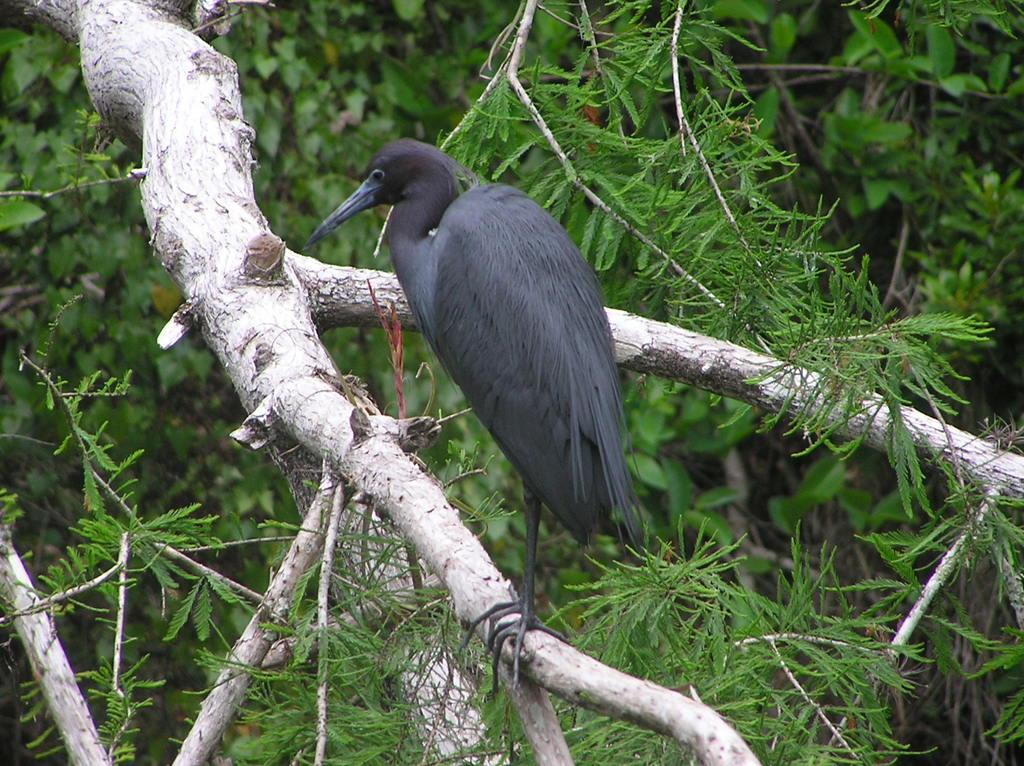What type of animal can be seen in the image? There is a bird in the image. Where is the bird located? The bird is on a tree branch. What can be seen in the background of the image? Leaves are visible in the background of the image. What type of crown is the bird wearing in the image? There is no crown present in the image; the bird is simply perched on a tree branch. 